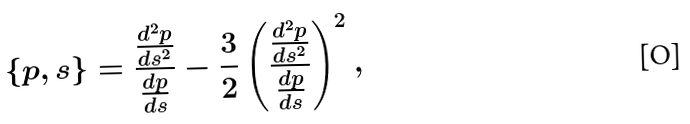Convert formula to latex. <formula><loc_0><loc_0><loc_500><loc_500>\{ p , s \} = \frac { \frac { d ^ { 2 } p } { d s ^ { 2 } } } { \frac { d p } { d s } } - \frac { 3 } { 2 } \left ( \frac { \frac { d ^ { 2 } p } { d s ^ { 2 } } } { \frac { d p } { d s } } \right ) ^ { 2 } ,</formula> 